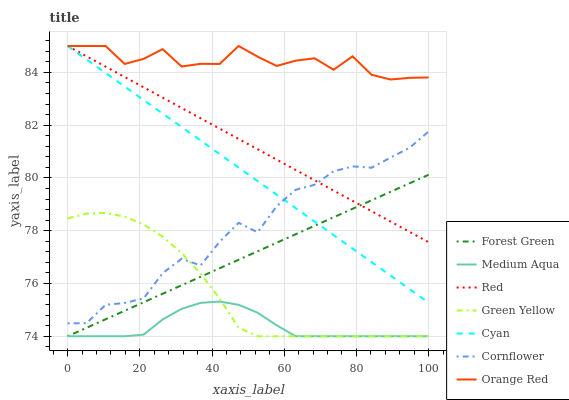Does Medium Aqua have the minimum area under the curve?
Answer yes or no. Yes. Does Orange Red have the maximum area under the curve?
Answer yes or no. Yes. Does Forest Green have the minimum area under the curve?
Answer yes or no. No. Does Forest Green have the maximum area under the curve?
Answer yes or no. No. Is Forest Green the smoothest?
Answer yes or no. Yes. Is Orange Red the roughest?
Answer yes or no. Yes. Is Medium Aqua the smoothest?
Answer yes or no. No. Is Medium Aqua the roughest?
Answer yes or no. No. Does Forest Green have the lowest value?
Answer yes or no. Yes. Does Cyan have the lowest value?
Answer yes or no. No. Does Red have the highest value?
Answer yes or no. Yes. Does Forest Green have the highest value?
Answer yes or no. No. Is Medium Aqua less than Red?
Answer yes or no. Yes. Is Cyan greater than Medium Aqua?
Answer yes or no. Yes. Does Red intersect Cornflower?
Answer yes or no. Yes. Is Red less than Cornflower?
Answer yes or no. No. Is Red greater than Cornflower?
Answer yes or no. No. Does Medium Aqua intersect Red?
Answer yes or no. No. 